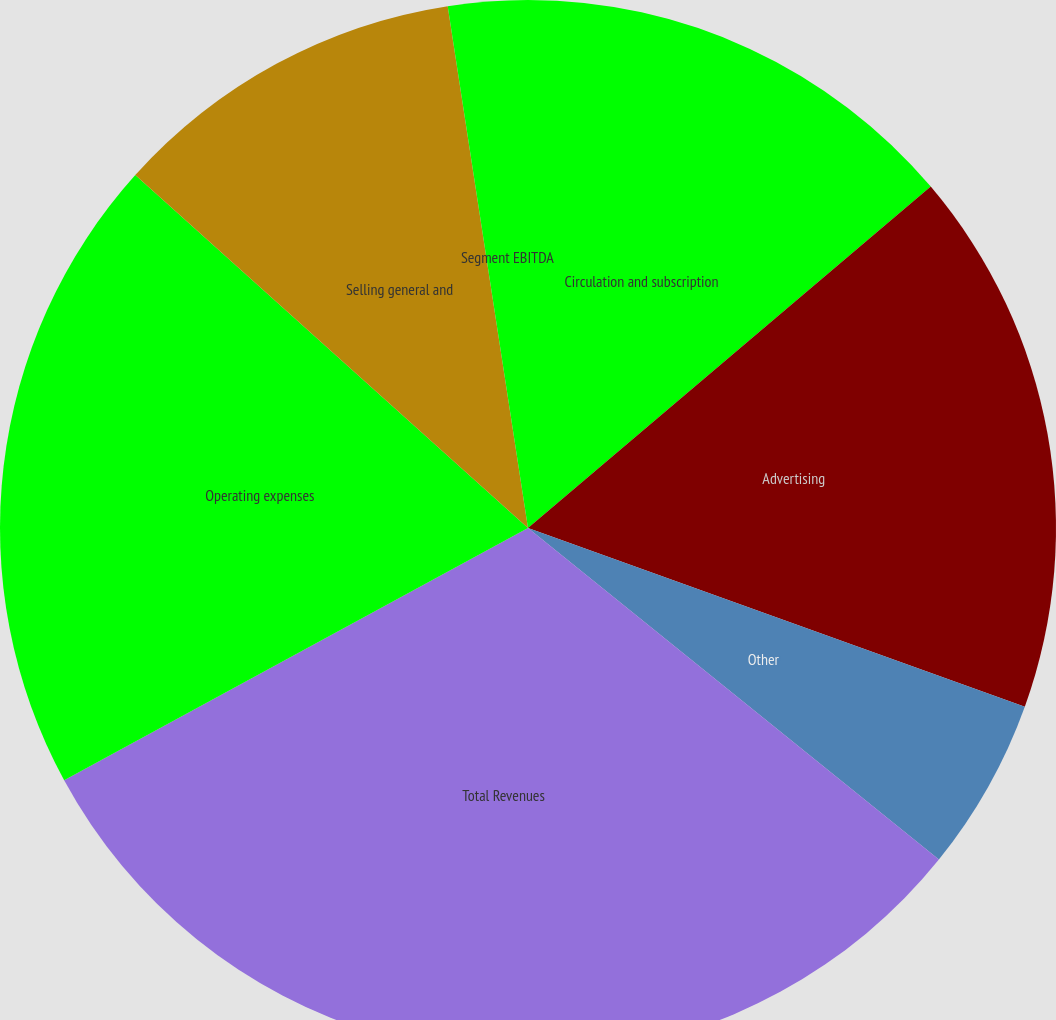<chart> <loc_0><loc_0><loc_500><loc_500><pie_chart><fcel>Circulation and subscription<fcel>Advertising<fcel>Other<fcel>Total Revenues<fcel>Operating expenses<fcel>Selling general and<fcel>Segment EBITDA<nl><fcel>13.81%<fcel>16.69%<fcel>5.31%<fcel>31.27%<fcel>19.58%<fcel>10.92%<fcel>2.43%<nl></chart> 